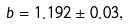<formula> <loc_0><loc_0><loc_500><loc_500>b = 1 . 1 9 2 \pm 0 . 0 3 ,</formula> 